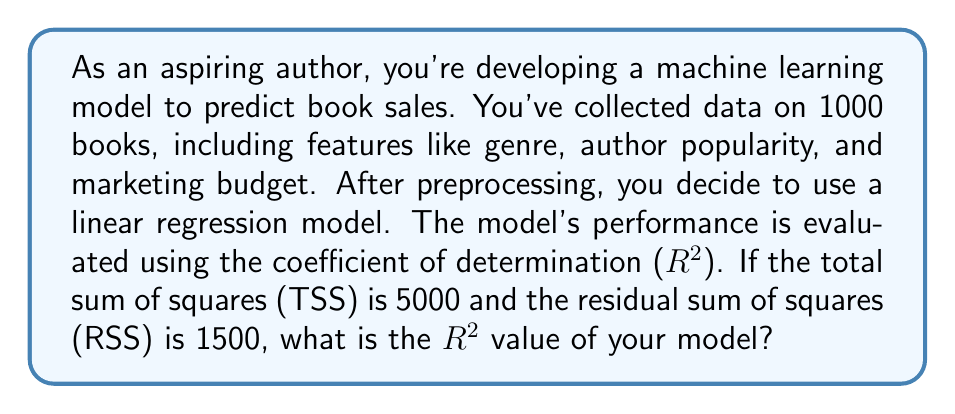Show me your answer to this math problem. To solve this problem, let's break it down step-by-step:

1. Understand the concept:
   R-squared (R²) is a statistical measure that represents the proportion of the variance in the dependent variable (book sales) that is predictable from the independent variables (genre, author popularity, marketing budget, etc.).

2. Recall the formula for R-squared:
   $$ R^2 = 1 - \frac{RSS}{TSS} $$
   Where:
   RSS = Residual Sum of Squares
   TSS = Total Sum of Squares

3. Identify the given values:
   TSS = 5000
   RSS = 1500

4. Plug the values into the formula:
   $$ R^2 = 1 - \frac{1500}{5000} $$

5. Simplify the fraction:
   $$ R^2 = 1 - \frac{3}{10} $$

6. Perform the subtraction:
   $$ R^2 = \frac{10}{10} - \frac{3}{10} = \frac{7}{10} = 0.7 $$

Therefore, the R-squared value of your model is 0.7 or 70%.

This means that approximately 70% of the variability in book sales can be explained by the features you've included in your model, which is a relatively good fit. However, there's still room for improvement, possibly by including additional relevant features or trying more advanced machine learning algorithms.
Answer: 0.7 or 70% 